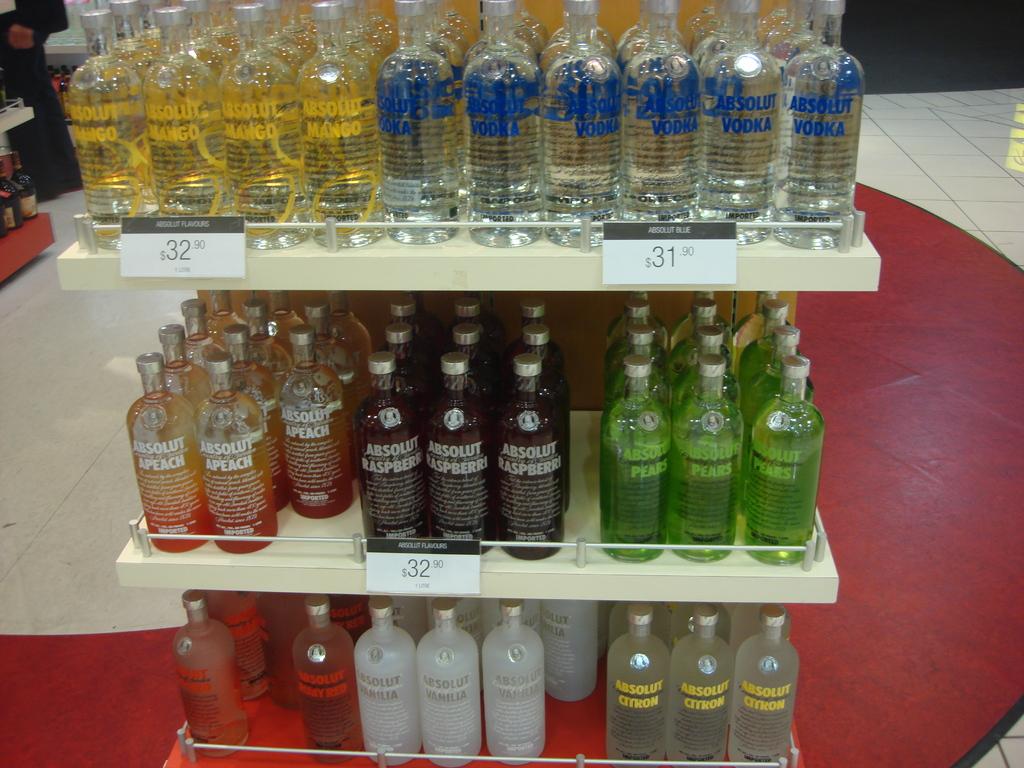How much is the mango vodka?
Your answer should be compact. 32.90. How many kind of vodka are there?
Keep it short and to the point. Answering does not require reading text in the image. 